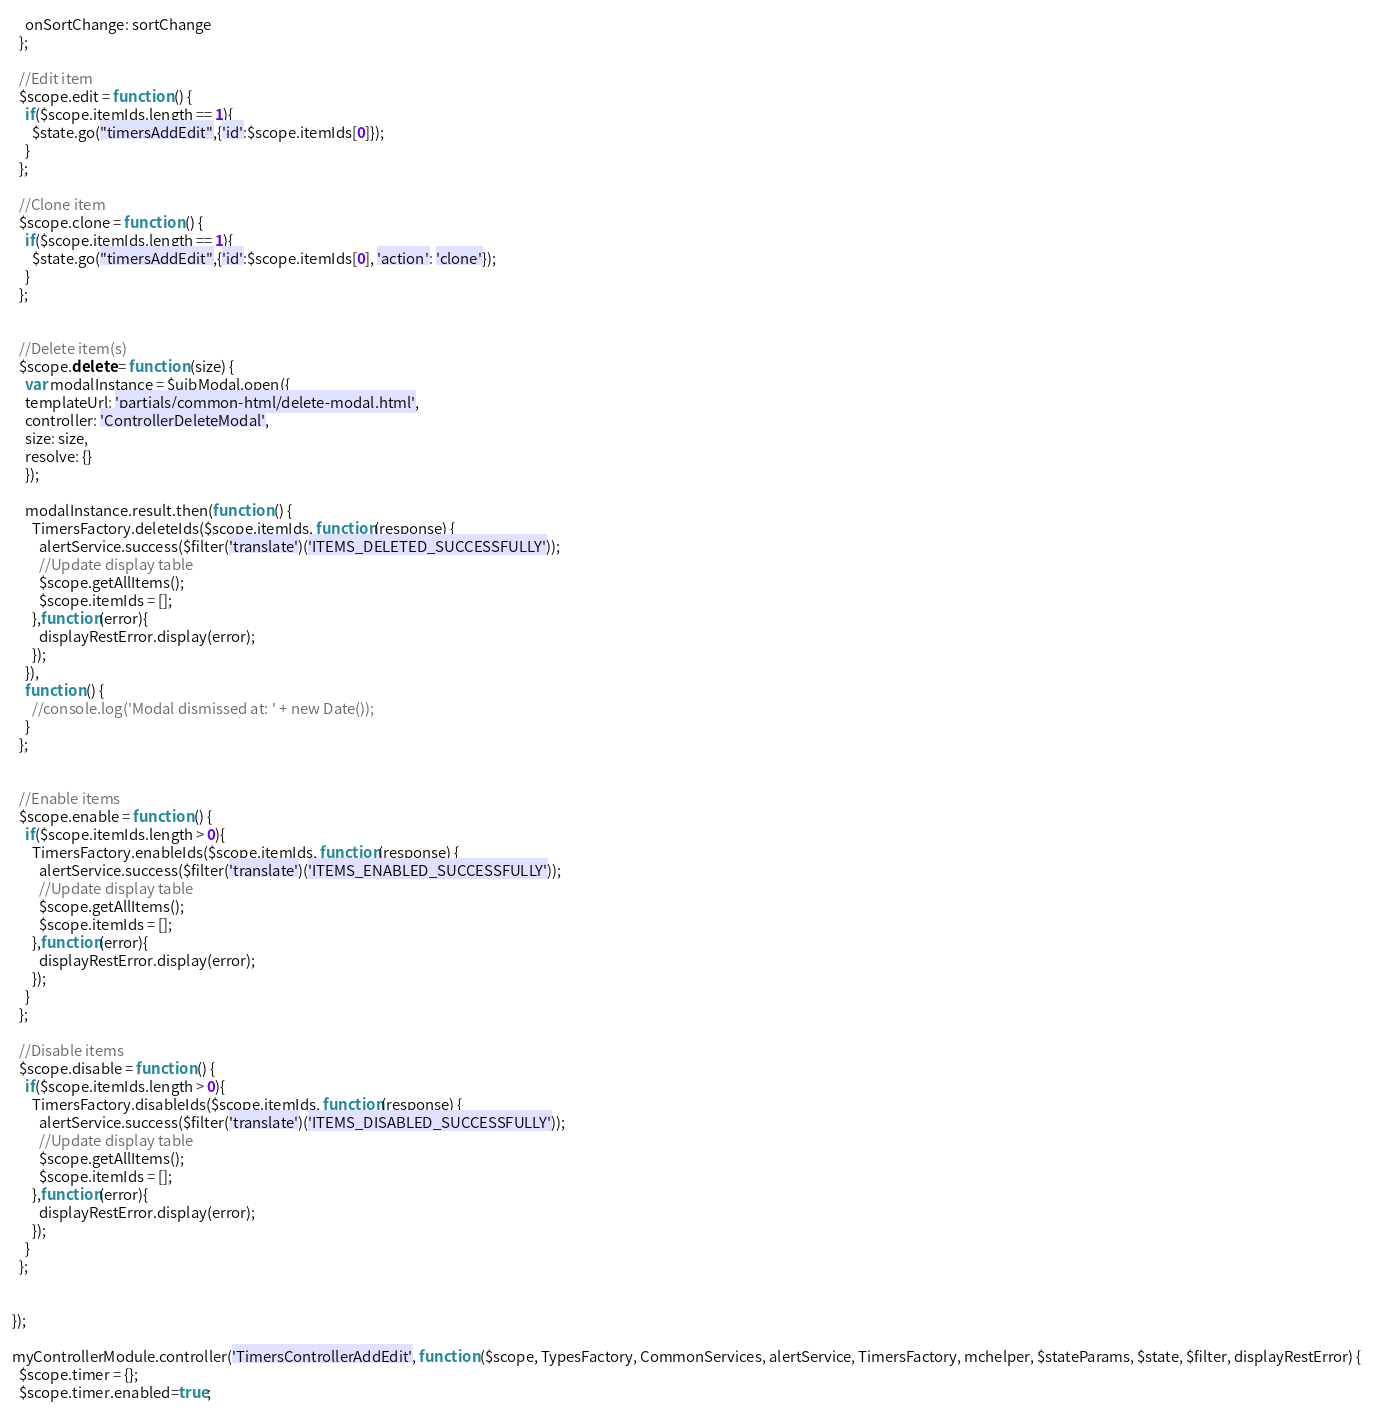<code> <loc_0><loc_0><loc_500><loc_500><_JavaScript_>    onSortChange: sortChange
  };

  //Edit item
  $scope.edit = function () {
    if($scope.itemIds.length == 1){
      $state.go("timersAddEdit",{'id':$scope.itemIds[0]});
    }
  };

  //Clone item
  $scope.clone = function () {
    if($scope.itemIds.length == 1){
      $state.go("timersAddEdit",{'id':$scope.itemIds[0], 'action': 'clone'});
    }
  };


  //Delete item(s)
  $scope.delete = function (size) {
    var modalInstance = $uibModal.open({
    templateUrl: 'partials/common-html/delete-modal.html',
    controller: 'ControllerDeleteModal',
    size: size,
    resolve: {}
    });

    modalInstance.result.then(function () {
      TimersFactory.deleteIds($scope.itemIds, function(response) {
        alertService.success($filter('translate')('ITEMS_DELETED_SUCCESSFULLY'));
        //Update display table
        $scope.getAllItems();
        $scope.itemIds = [];
      },function(error){
        displayRestError.display(error);
      });
    }),
    function () {
      //console.log('Modal dismissed at: ' + new Date());
    }
  };


  //Enable items
  $scope.enable = function () {
    if($scope.itemIds.length > 0){
      TimersFactory.enableIds($scope.itemIds, function(response) {
        alertService.success($filter('translate')('ITEMS_ENABLED_SUCCESSFULLY'));
        //Update display table
        $scope.getAllItems();
        $scope.itemIds = [];
      },function(error){
        displayRestError.display(error);
      });
    }
  };

  //Disable items
  $scope.disable = function () {
    if($scope.itemIds.length > 0){
      TimersFactory.disableIds($scope.itemIds, function(response) {
        alertService.success($filter('translate')('ITEMS_DISABLED_SUCCESSFULLY'));
        //Update display table
        $scope.getAllItems();
        $scope.itemIds = [];
      },function(error){
        displayRestError.display(error);
      });
    }
  };


});

myControllerModule.controller('TimersControllerAddEdit', function ($scope, TypesFactory, CommonServices, alertService, TimersFactory, mchelper, $stateParams, $state, $filter, displayRestError) {
  $scope.timer = {};
  $scope.timer.enabled=true;</code> 